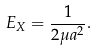Convert formula to latex. <formula><loc_0><loc_0><loc_500><loc_500>E _ { X } = \frac { 1 } { 2 \mu a ^ { 2 } } .</formula> 